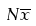<formula> <loc_0><loc_0><loc_500><loc_500>N \overline { x }</formula> 